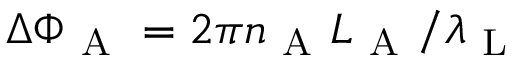<formula> <loc_0><loc_0><loc_500><loc_500>\Delta \Phi _ { A } = 2 \pi n _ { A } L _ { A } / \lambda _ { L }</formula> 